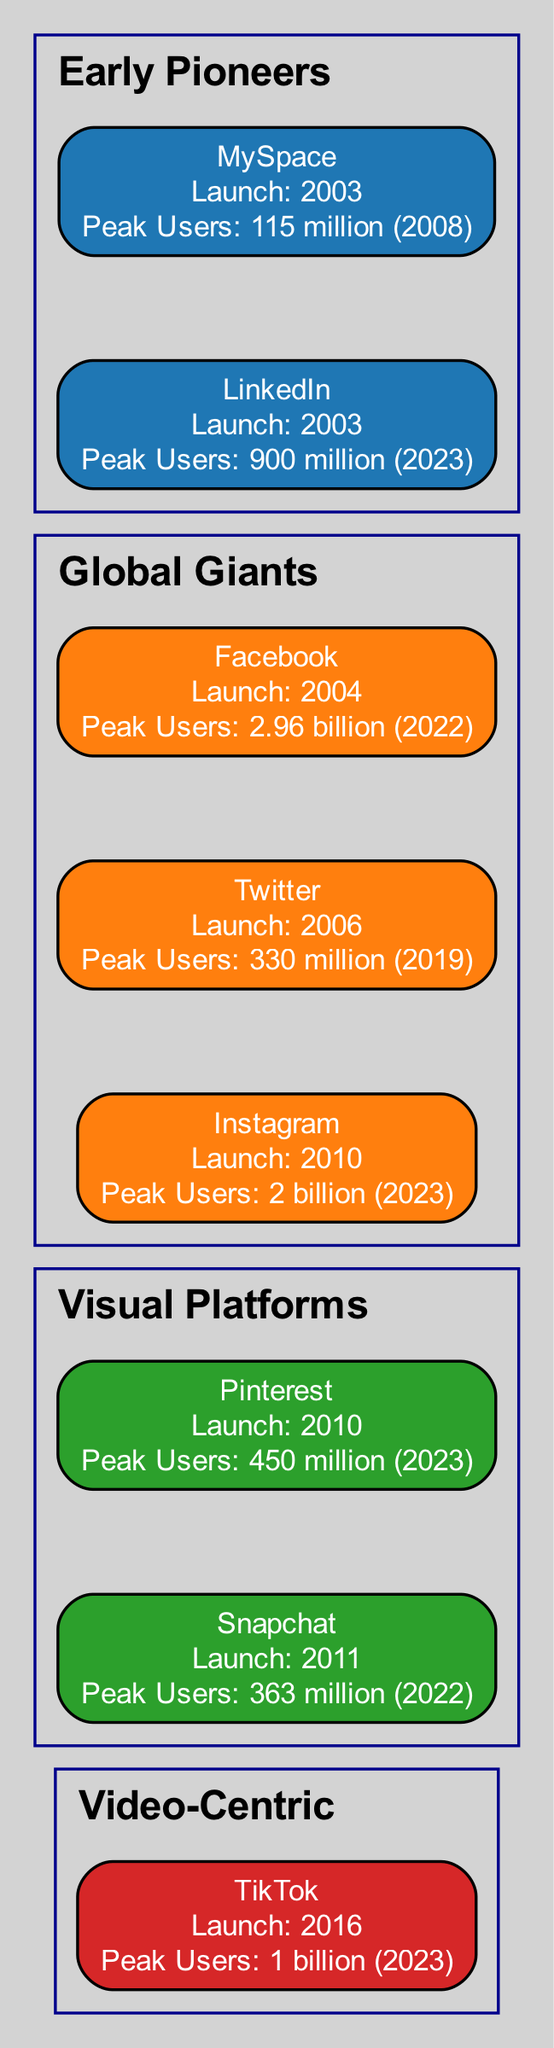What year was Facebook launched? Facebook was launched in the year 2004, as indicated in the diagram under the Global Giants category.
Answer: 2004 Which platform had the highest peak users? The diagram shows that Facebook had the highest peak users, with 2.96 billion in 2022, making it the leading platform in user numbers.
Answer: 2.96 billion How many visual platforms are listed in the diagram? The diagram includes two visual platforms: Pinterest and Snapchat, which can be counted under the Visual Platforms category.
Answer: 2 What was the peak user number of MySpace? According to the information provided in the diagram, MySpace reached a peak user number of 115 million in 2008.
Answer: 115 million Which platform was launched first, Instagram or Snapchat? The diagram shows that Instagram was launched in 2010 and Snapchat in 2011, indicating Instagram was launched earlier.
Answer: Instagram What is the category of LinkedIn? The diagram categorizes LinkedIn under Early Pioneers, which is stated in the hierarchy of social media platforms.
Answer: Early Pioneers Which platform launched in 2010 has a peak user number of 450 million? The diagram indicates that Pinterest, which launched in 2010, has a peak user number of 450 million in 2023.
Answer: Pinterest What do the invisible edges in the diagram represent? The invisible edges in the diagram represent the chronological order of the social media platforms' launches, connecting them in sequence by launch date.
Answer: Chronological order Which platform falls under the Video-Centric classification? The diagram clearly indicates that TikTok is categorized under Video-Centric, distinguishing it from other platforms.
Answer: TikTok 